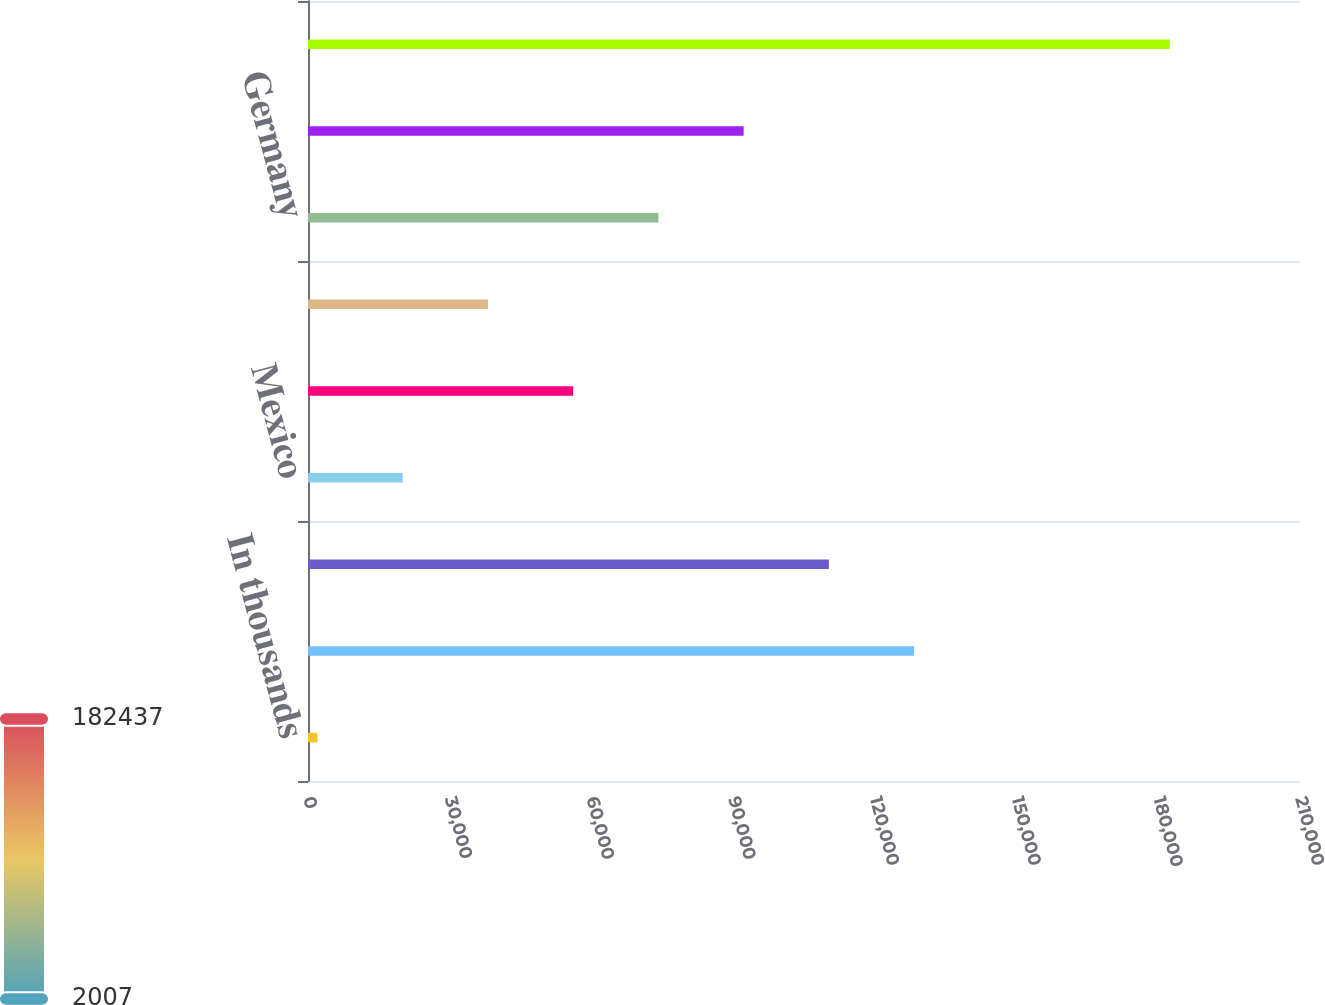<chart> <loc_0><loc_0><loc_500><loc_500><bar_chart><fcel>In thousands<fcel>United States<fcel>Canada<fcel>Mexico<fcel>United Kingdom<fcel>Australia<fcel>Germany<fcel>Other international<fcel>Total<nl><fcel>2007<fcel>128308<fcel>110265<fcel>20050<fcel>56136<fcel>38093<fcel>74179<fcel>92222<fcel>182437<nl></chart> 